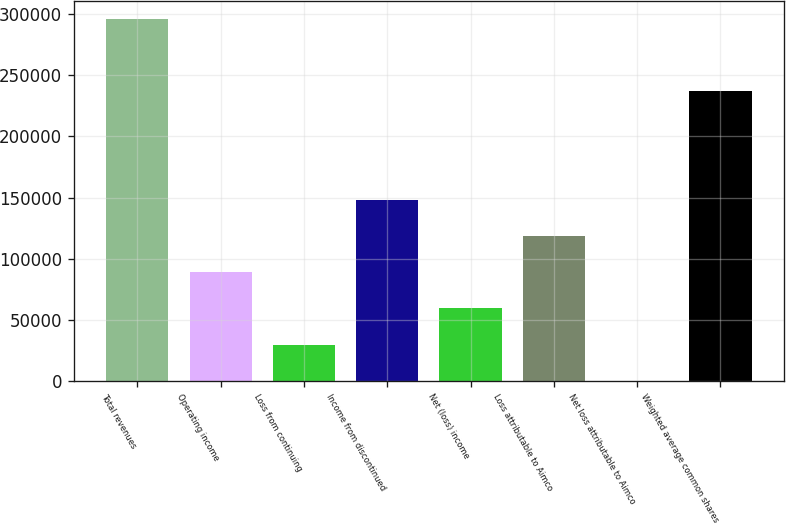Convert chart to OTSL. <chart><loc_0><loc_0><loc_500><loc_500><bar_chart><fcel>Total revenues<fcel>Operating income<fcel>Loss from continuing<fcel>Income from discontinued<fcel>Net (loss) income<fcel>Loss attributable to Aimco<fcel>Net loss attributable to Aimco<fcel>Weighted average common shares<nl><fcel>296396<fcel>88919.1<fcel>29639.9<fcel>148198<fcel>59279.5<fcel>118559<fcel>0.34<fcel>237117<nl></chart> 